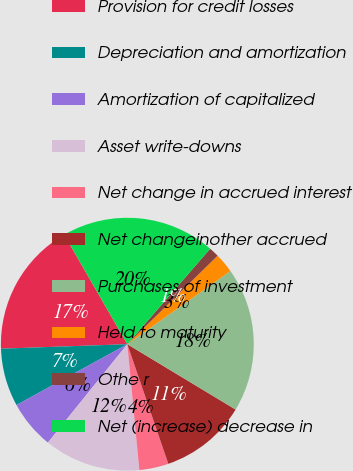Convert chart. <chart><loc_0><loc_0><loc_500><loc_500><pie_chart><fcel>Provision for credit losses<fcel>Depreciation and amortization<fcel>Amortization of capitalized<fcel>Asset write-downs<fcel>Net change in accrued interest<fcel>Net changeinother accrued<fcel>Purchases of investment<fcel>Held to maturity<fcel>Othe r<fcel>Net (increase) decrease in<nl><fcel>17.24%<fcel>7.42%<fcel>6.2%<fcel>12.33%<fcel>3.74%<fcel>11.1%<fcel>18.47%<fcel>2.51%<fcel>1.29%<fcel>19.69%<nl></chart> 